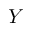Convert formula to latex. <formula><loc_0><loc_0><loc_500><loc_500>Y</formula> 